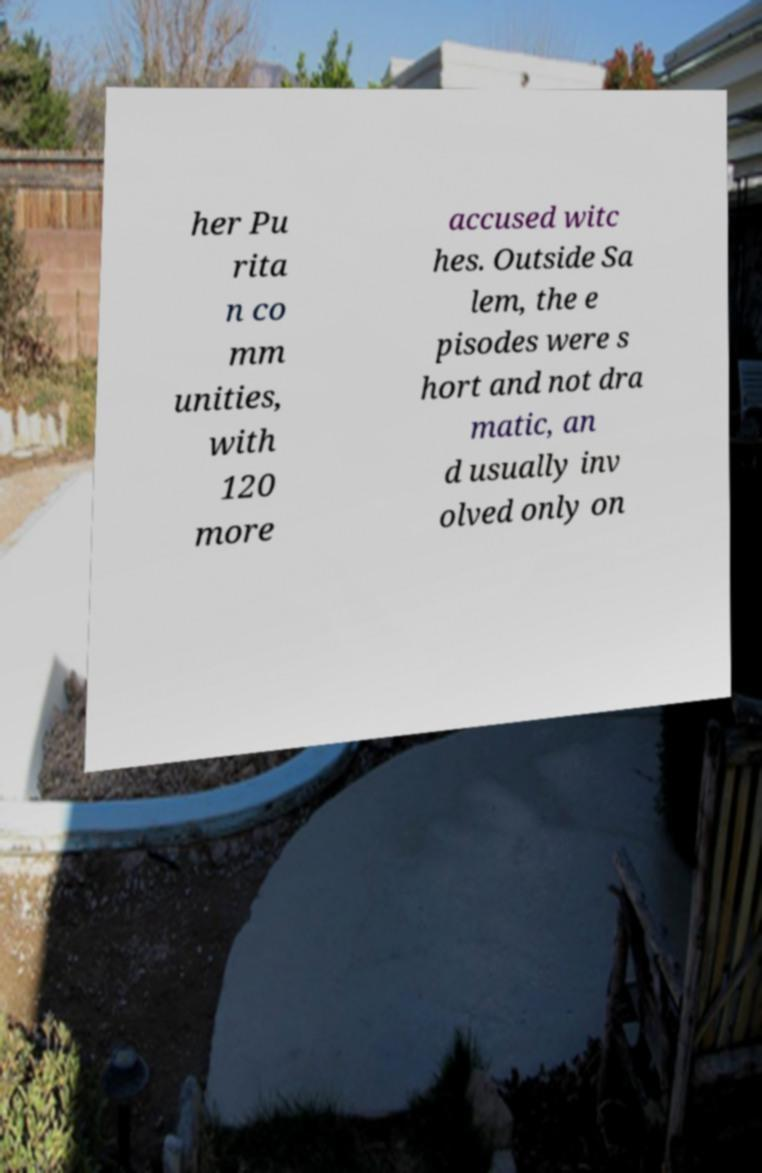There's text embedded in this image that I need extracted. Can you transcribe it verbatim? her Pu rita n co mm unities, with 120 more accused witc hes. Outside Sa lem, the e pisodes were s hort and not dra matic, an d usually inv olved only on 